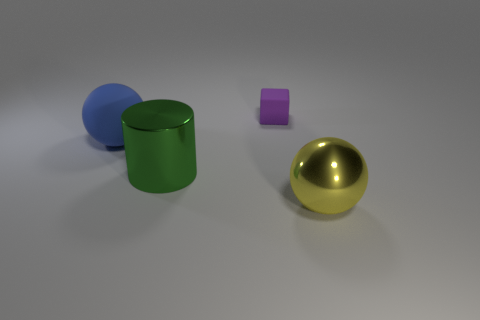What number of objects are metallic things that are to the right of the cube or tiny matte cubes?
Your response must be concise. 2. The cube that is the same material as the large blue ball is what size?
Ensure brevity in your answer.  Small. Is the number of large balls on the left side of the shiny ball greater than the number of blue cubes?
Give a very brief answer. Yes. There is a large yellow metal thing; is it the same shape as the shiny object to the left of the large metallic sphere?
Give a very brief answer. No. What number of tiny things are either red shiny cylinders or metallic cylinders?
Give a very brief answer. 0. The large ball that is to the right of the big cylinder that is to the right of the large rubber thing is what color?
Your answer should be compact. Yellow. Is the material of the blue object the same as the big object that is on the right side of the tiny purple object?
Your answer should be compact. No. There is a sphere that is to the right of the blue matte object; what is it made of?
Ensure brevity in your answer.  Metal. Are there an equal number of purple objects in front of the matte ball and brown rubber spheres?
Provide a short and direct response. Yes. Are there any other things that are the same size as the matte block?
Your answer should be compact. No. 